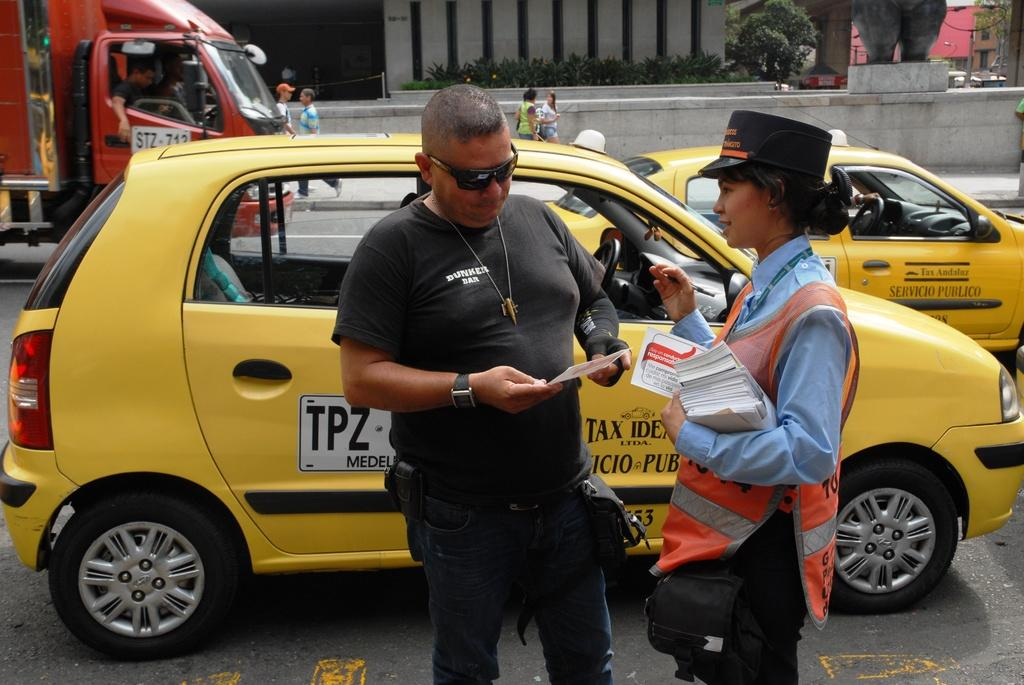<image>
Summarize the visual content of the image. The guy is wear a black t-shirt saying 'Dunker Bar'. 